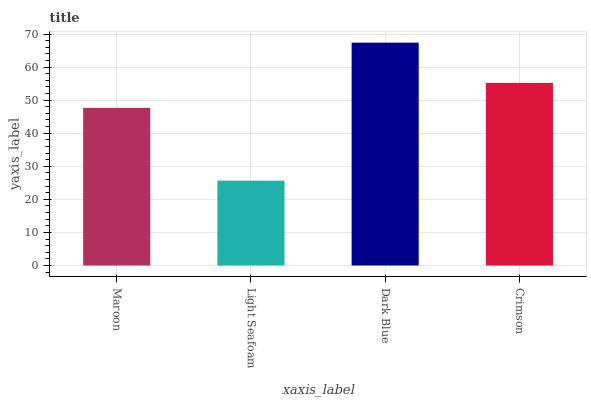Is Light Seafoam the minimum?
Answer yes or no. Yes. Is Dark Blue the maximum?
Answer yes or no. Yes. Is Dark Blue the minimum?
Answer yes or no. No. Is Light Seafoam the maximum?
Answer yes or no. No. Is Dark Blue greater than Light Seafoam?
Answer yes or no. Yes. Is Light Seafoam less than Dark Blue?
Answer yes or no. Yes. Is Light Seafoam greater than Dark Blue?
Answer yes or no. No. Is Dark Blue less than Light Seafoam?
Answer yes or no. No. Is Crimson the high median?
Answer yes or no. Yes. Is Maroon the low median?
Answer yes or no. Yes. Is Maroon the high median?
Answer yes or no. No. Is Crimson the low median?
Answer yes or no. No. 